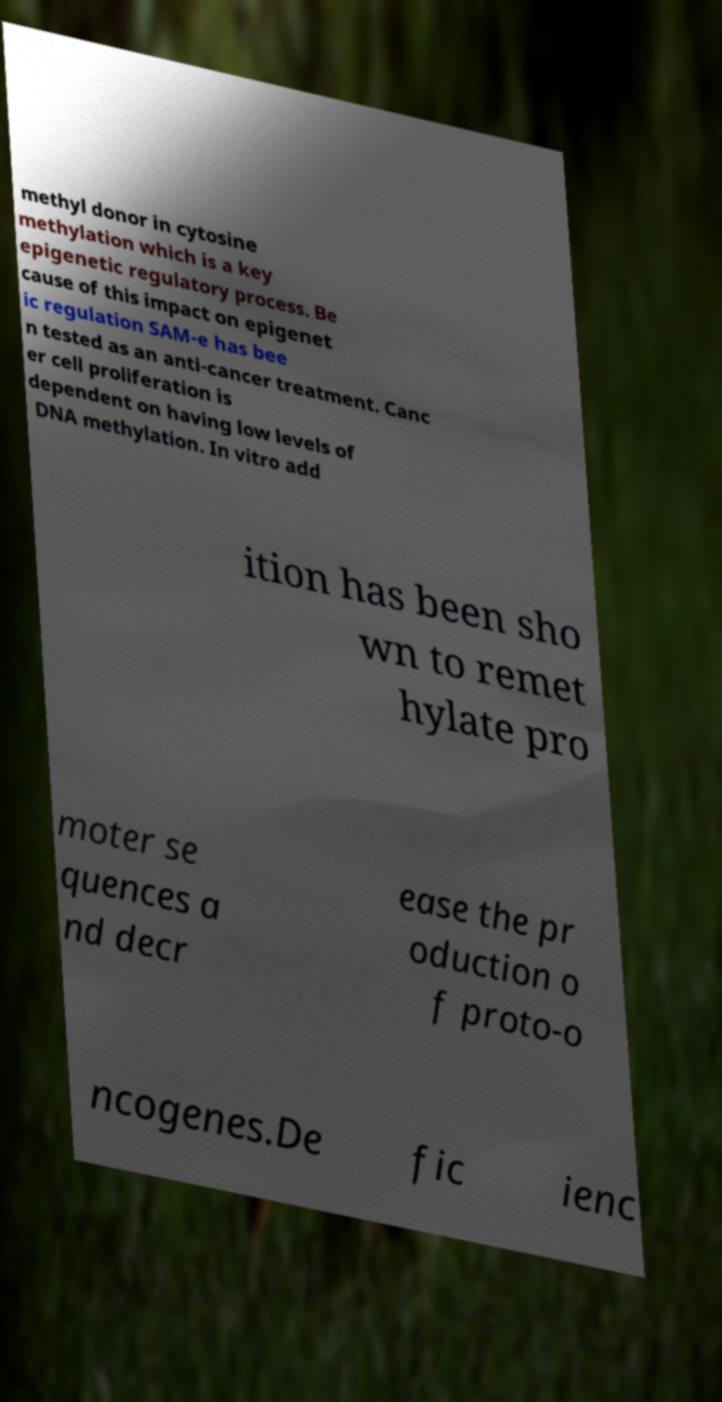For documentation purposes, I need the text within this image transcribed. Could you provide that? methyl donor in cytosine methylation which is a key epigenetic regulatory process. Be cause of this impact on epigenet ic regulation SAM-e has bee n tested as an anti-cancer treatment. Canc er cell proliferation is dependent on having low levels of DNA methylation. In vitro add ition has been sho wn to remet hylate pro moter se quences a nd decr ease the pr oduction o f proto-o ncogenes.De fic ienc 